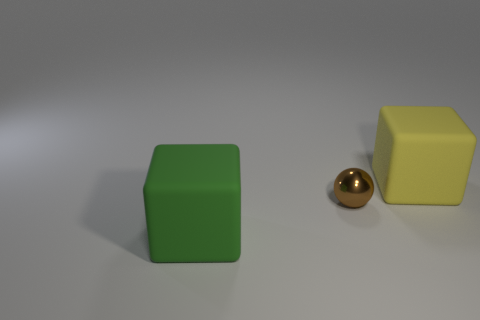What number of other things are there of the same material as the small ball
Provide a succinct answer. 0. What is the shape of the green thing that is the same size as the yellow rubber thing?
Keep it short and to the point. Cube. Are there more green things than tiny matte things?
Offer a very short reply. Yes. Are the small brown object and the green thing made of the same material?
Ensure brevity in your answer.  No. Are there the same number of tiny brown things that are to the left of the small brown sphere and large things?
Your answer should be compact. No. How many brown balls have the same material as the large green object?
Make the answer very short. 0. Are there fewer big green cubes than blocks?
Give a very brief answer. Yes. How many large green blocks are in front of the big matte object in front of the large thing that is on the right side of the brown shiny object?
Offer a very short reply. 0. How many rubber objects are in front of the big yellow block?
Offer a terse response. 1. There is another matte thing that is the same shape as the green object; what color is it?
Ensure brevity in your answer.  Yellow. 